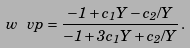Convert formula to latex. <formula><loc_0><loc_0><loc_500><loc_500>w _ { \ } v p = \frac { - 1 + c _ { 1 } Y - c _ { 2 } / Y } { - 1 + 3 c _ { 1 } Y + c _ { 2 } / Y } \, .</formula> 